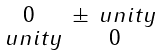<formula> <loc_0><loc_0><loc_500><loc_500>\begin{smallmatrix} 0 & \pm { \ u n i t y } \\ { \ u n i t y } & 0 \end{smallmatrix}</formula> 